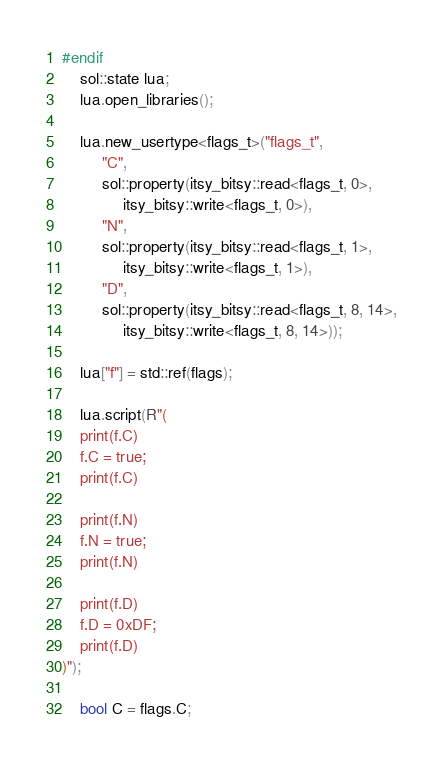<code> <loc_0><loc_0><loc_500><loc_500><_C++_>#endif
	sol::state lua;
	lua.open_libraries();

	lua.new_usertype<flags_t>("flags_t",
	     "C",
	     sol::property(itsy_bitsy::read<flags_t, 0>,
	          itsy_bitsy::write<flags_t, 0>),
	     "N",
	     sol::property(itsy_bitsy::read<flags_t, 1>,
	          itsy_bitsy::write<flags_t, 1>),
	     "D",
	     sol::property(itsy_bitsy::read<flags_t, 8, 14>,
	          itsy_bitsy::write<flags_t, 8, 14>));

	lua["f"] = std::ref(flags);

	lua.script(R"(
    print(f.C)
    f.C = true;
    print(f.C)

    print(f.N)
    f.N = true;
    print(f.N)

    print(f.D)
    f.D = 0xDF;
    print(f.D)
)");

	bool C = flags.C;</code> 